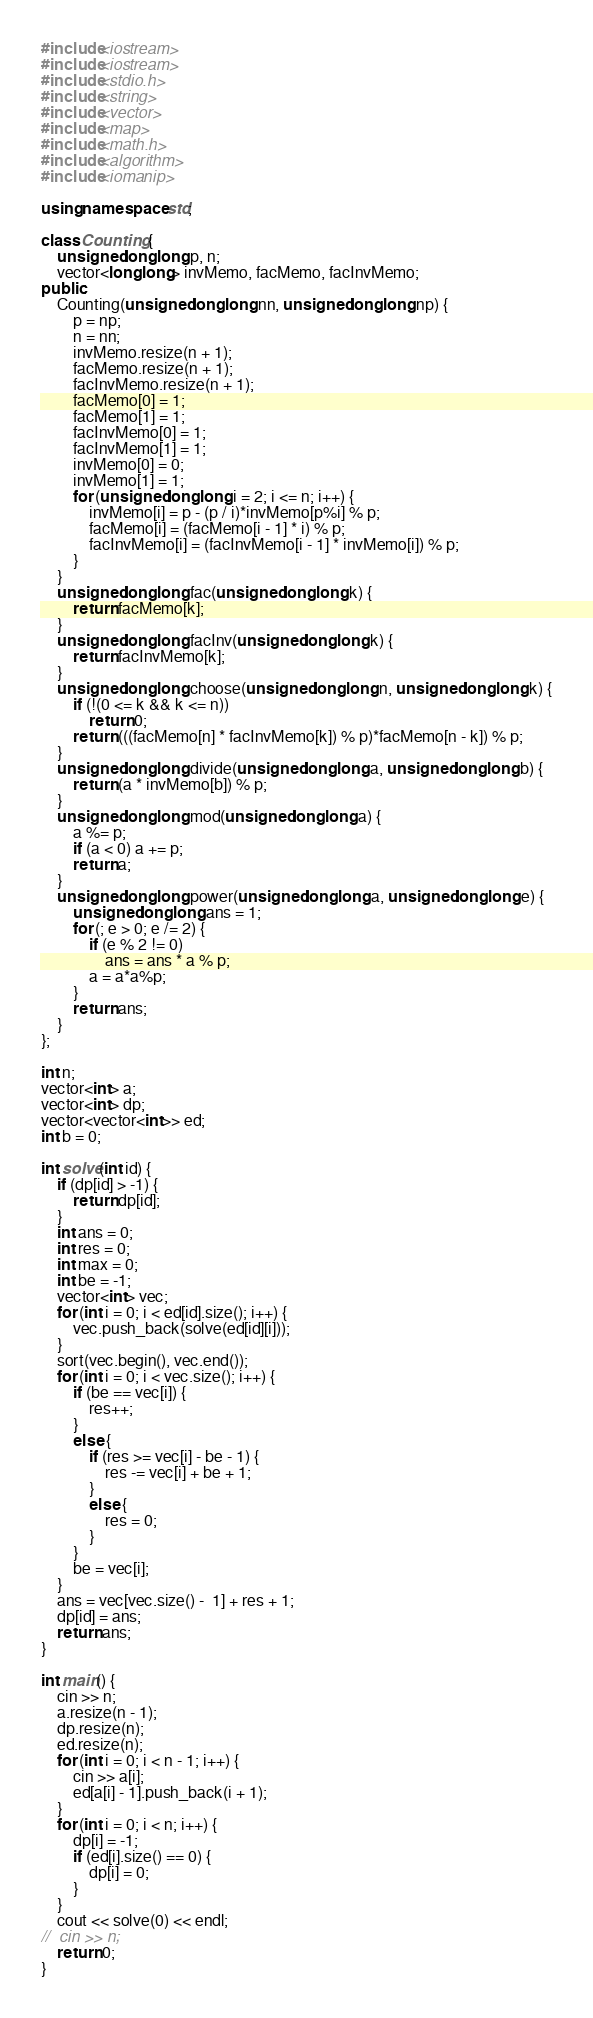<code> <loc_0><loc_0><loc_500><loc_500><_C++_>#include<iostream>
#include<iostream>
#include<stdio.h>
#include<string>
#include<vector>
#include<map>
#include<math.h>
#include<algorithm>
#include<iomanip>

using namespace std;

class Counting {
	unsigned long long p, n;
	vector<long long> invMemo, facMemo, facInvMemo;
public:
	Counting(unsigned long long nn, unsigned long long np) {
		p = np;
		n = nn;
		invMemo.resize(n + 1);
		facMemo.resize(n + 1);
		facInvMemo.resize(n + 1);
		facMemo[0] = 1;
		facMemo[1] = 1;
		facInvMemo[0] = 1;
		facInvMemo[1] = 1;
		invMemo[0] = 0;
		invMemo[1] = 1;
		for (unsigned long long i = 2; i <= n; i++) {
			invMemo[i] = p - (p / i)*invMemo[p%i] % p;
			facMemo[i] = (facMemo[i - 1] * i) % p;
			facInvMemo[i] = (facInvMemo[i - 1] * invMemo[i]) % p;
		}
	}
	unsigned long long fac(unsigned long long k) {
		return facMemo[k];
	}
	unsigned long long facInv(unsigned long long k) {
		return facInvMemo[k];
	}
	unsigned long long choose(unsigned long long n, unsigned long long k) {
		if (!(0 <= k && k <= n))
			return 0;
		return (((facMemo[n] * facInvMemo[k]) % p)*facMemo[n - k]) % p;
	}
	unsigned long long divide(unsigned long long a, unsigned long long b) {
		return (a * invMemo[b]) % p;
	}
	unsigned long long mod(unsigned long long a) {
		a %= p;
		if (a < 0) a += p;
		return a;
	}
	unsigned long long power(unsigned long long a, unsigned long long e) {
		unsigned long long ans = 1;
		for (; e > 0; e /= 2) {
			if (e % 2 != 0)
				ans = ans * a % p;
			a = a*a%p;
		}
		return ans;
	}
};

int n;
vector<int> a;
vector<int> dp;
vector<vector<int>> ed;
int b = 0;

int solve(int id) {
	if (dp[id] > -1) {
		return dp[id];
	}
	int ans = 0;
	int res = 0;
	int max = 0;
	int be = -1;
	vector<int> vec;
	for (int i = 0; i < ed[id].size(); i++) {
		vec.push_back(solve(ed[id][i]));
	}
	sort(vec.begin(), vec.end());
	for (int i = 0; i < vec.size(); i++) {
		if (be == vec[i]) {
			res++;
		}
		else {
			if (res >= vec[i] - be - 1) {
				res -= vec[i] + be + 1;
			}
			else {
				res = 0;
			}
		}
		be = vec[i];
	}
	ans = vec[vec.size() -  1] + res + 1;
	dp[id] = ans;
	return ans;
}

int main() {
	cin >> n;
	a.resize(n - 1);
	dp.resize(n);
	ed.resize(n);
	for (int i = 0; i < n - 1; i++) {
		cin >> a[i];
		ed[a[i] - 1].push_back(i + 1);
	}
	for (int i = 0; i < n; i++) {
		dp[i] = -1;
		if (ed[i].size() == 0) {
			dp[i] = 0;
		}
	}
	cout << solve(0) << endl;
//	cin >> n;
	return 0;
}</code> 